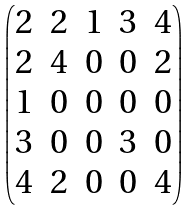Convert formula to latex. <formula><loc_0><loc_0><loc_500><loc_500>\begin{pmatrix} 2 & 2 & 1 & 3 & 4 \\ 2 & 4 & 0 & 0 & 2 \\ 1 & 0 & 0 & 0 & 0 \\ 3 & 0 & 0 & 3 & 0 \\ 4 & 2 & 0 & 0 & 4 \end{pmatrix}</formula> 